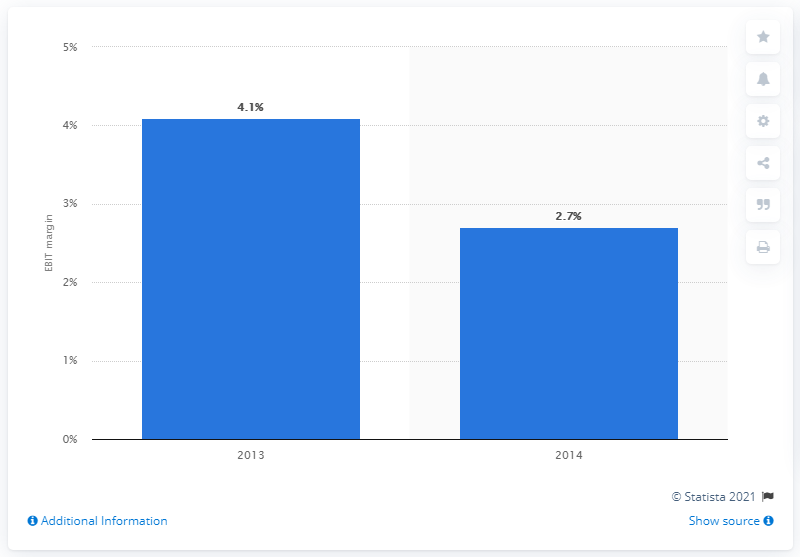Identify some key points in this picture. According to data from 2013, the EBIT margin of the leading U.S. automobile manufacturers was 4.1%. 